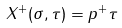<formula> <loc_0><loc_0><loc_500><loc_500>X ^ { + } ( \sigma , \tau ) = p ^ { + } \tau</formula> 